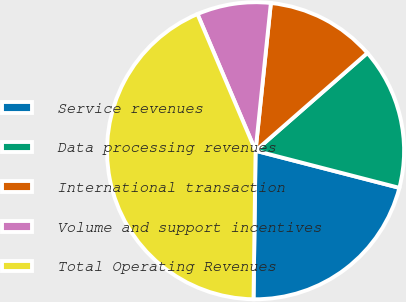Convert chart to OTSL. <chart><loc_0><loc_0><loc_500><loc_500><pie_chart><fcel>Service revenues<fcel>Data processing revenues<fcel>International transaction<fcel>Volume and support incentives<fcel>Total Operating Revenues<nl><fcel>21.2%<fcel>15.45%<fcel>11.92%<fcel>8.04%<fcel>43.38%<nl></chart> 